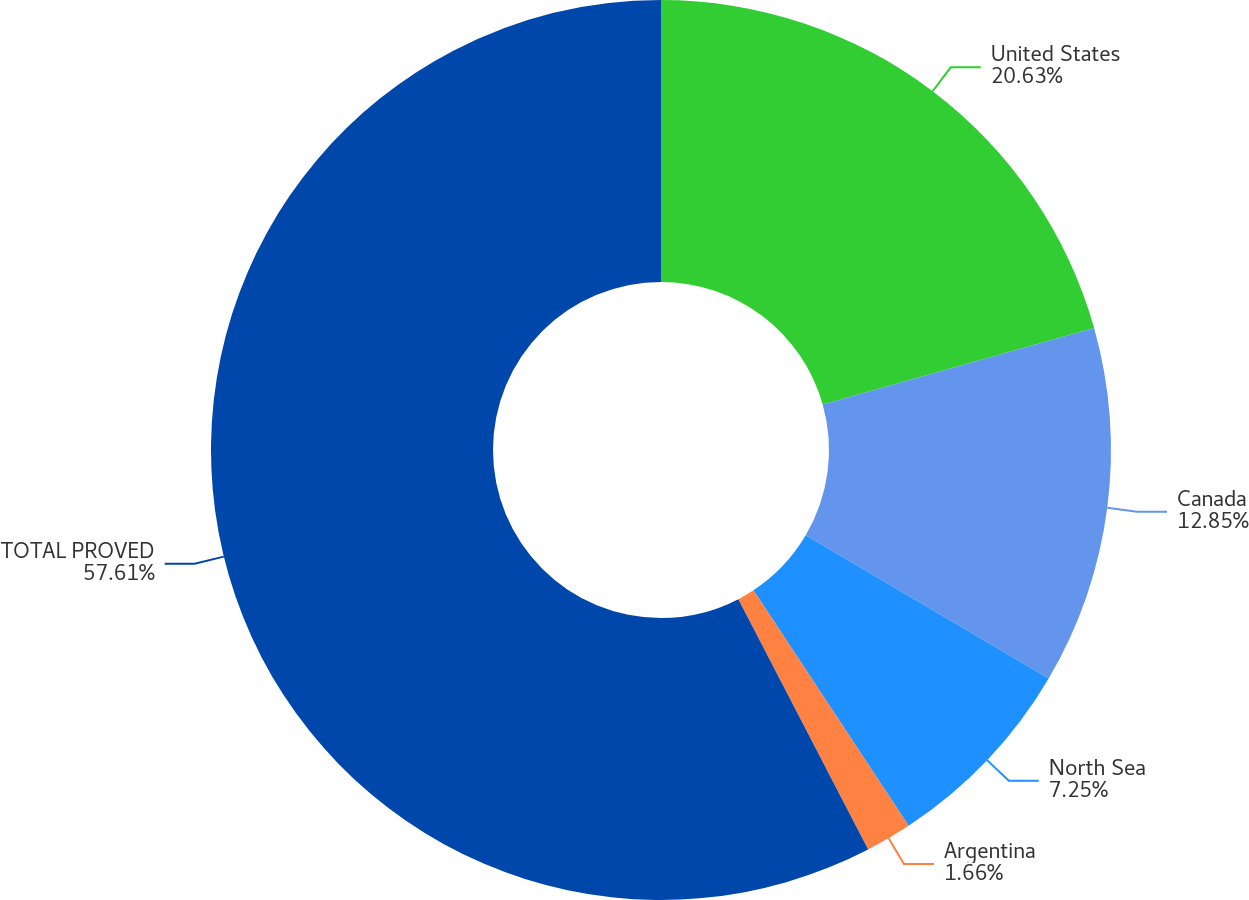Convert chart. <chart><loc_0><loc_0><loc_500><loc_500><pie_chart><fcel>United States<fcel>Canada<fcel>North Sea<fcel>Argentina<fcel>TOTAL PROVED<nl><fcel>20.63%<fcel>12.85%<fcel>7.25%<fcel>1.66%<fcel>57.62%<nl></chart> 